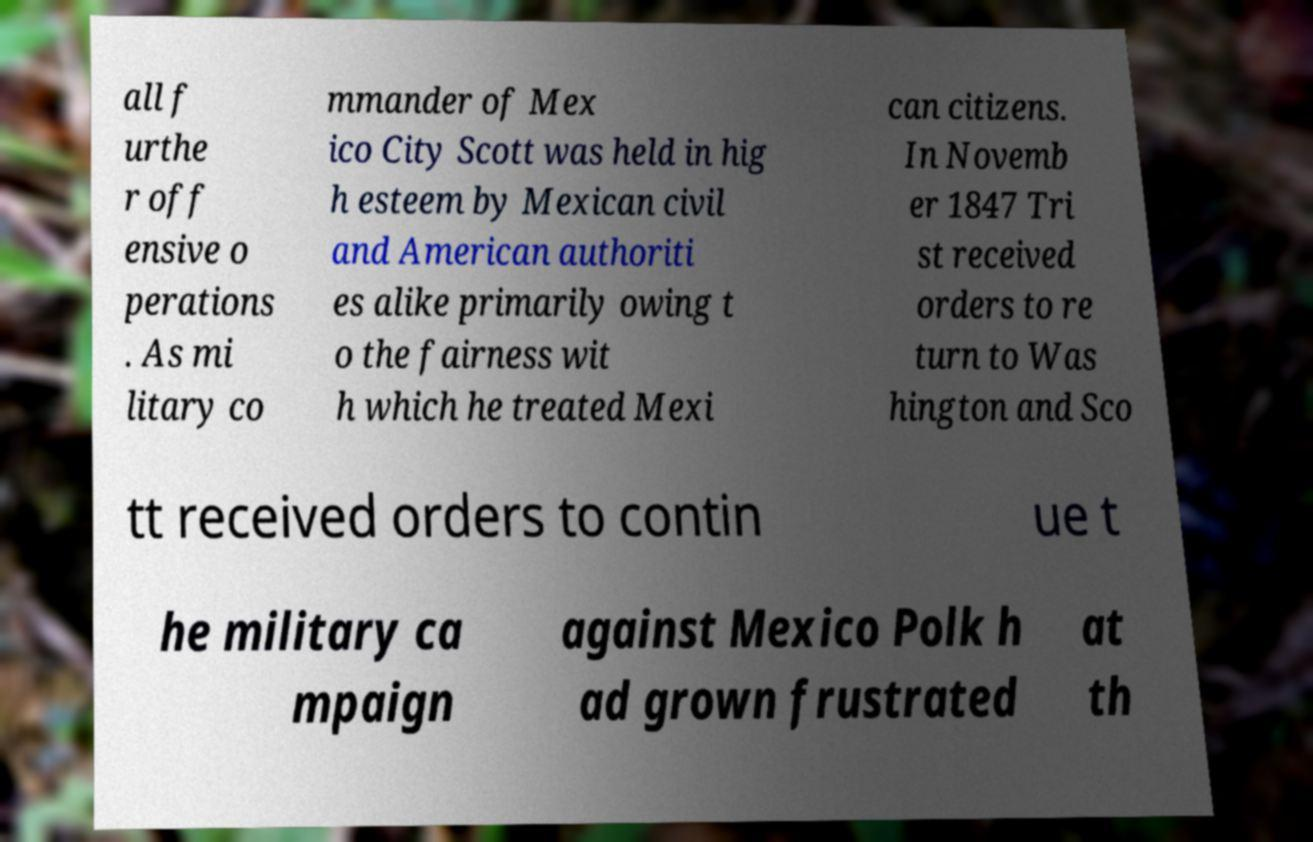What messages or text are displayed in this image? I need them in a readable, typed format. all f urthe r off ensive o perations . As mi litary co mmander of Mex ico City Scott was held in hig h esteem by Mexican civil and American authoriti es alike primarily owing t o the fairness wit h which he treated Mexi can citizens. In Novemb er 1847 Tri st received orders to re turn to Was hington and Sco tt received orders to contin ue t he military ca mpaign against Mexico Polk h ad grown frustrated at th 